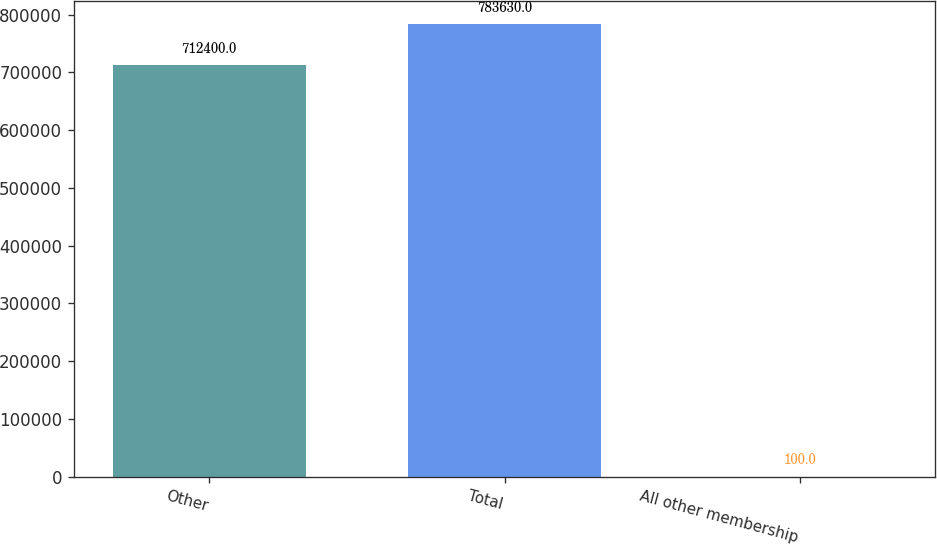Convert chart to OTSL. <chart><loc_0><loc_0><loc_500><loc_500><bar_chart><fcel>Other<fcel>Total<fcel>All other membership<nl><fcel>712400<fcel>783630<fcel>100<nl></chart> 